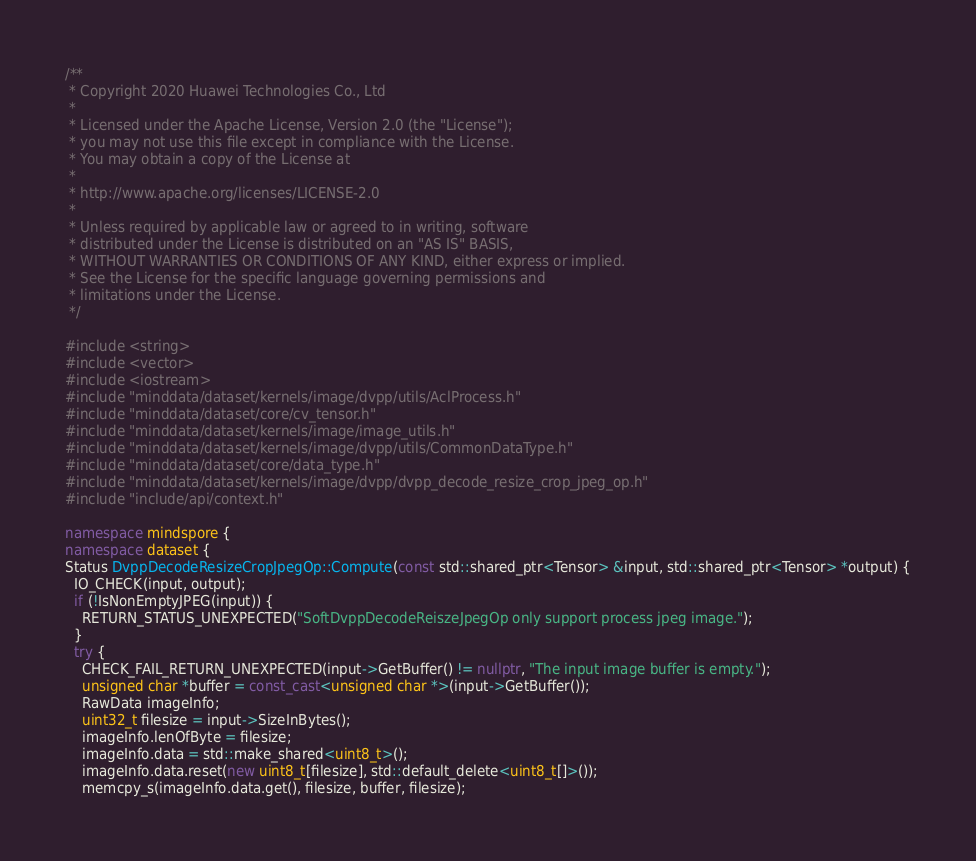<code> <loc_0><loc_0><loc_500><loc_500><_C++_>/**
 * Copyright 2020 Huawei Technologies Co., Ltd
 *
 * Licensed under the Apache License, Version 2.0 (the "License");
 * you may not use this file except in compliance with the License.
 * You may obtain a copy of the License at
 *
 * http://www.apache.org/licenses/LICENSE-2.0
 *
 * Unless required by applicable law or agreed to in writing, software
 * distributed under the License is distributed on an "AS IS" BASIS,
 * WITHOUT WARRANTIES OR CONDITIONS OF ANY KIND, either express or implied.
 * See the License for the specific language governing permissions and
 * limitations under the License.
 */

#include <string>
#include <vector>
#include <iostream>
#include "minddata/dataset/kernels/image/dvpp/utils/AclProcess.h"
#include "minddata/dataset/core/cv_tensor.h"
#include "minddata/dataset/kernels/image/image_utils.h"
#include "minddata/dataset/kernels/image/dvpp/utils/CommonDataType.h"
#include "minddata/dataset/core/data_type.h"
#include "minddata/dataset/kernels/image/dvpp/dvpp_decode_resize_crop_jpeg_op.h"
#include "include/api/context.h"

namespace mindspore {
namespace dataset {
Status DvppDecodeResizeCropJpegOp::Compute(const std::shared_ptr<Tensor> &input, std::shared_ptr<Tensor> *output) {
  IO_CHECK(input, output);
  if (!IsNonEmptyJPEG(input)) {
    RETURN_STATUS_UNEXPECTED("SoftDvppDecodeReiszeJpegOp only support process jpeg image.");
  }
  try {
    CHECK_FAIL_RETURN_UNEXPECTED(input->GetBuffer() != nullptr, "The input image buffer is empty.");
    unsigned char *buffer = const_cast<unsigned char *>(input->GetBuffer());
    RawData imageInfo;
    uint32_t filesize = input->SizeInBytes();
    imageInfo.lenOfByte = filesize;
    imageInfo.data = std::make_shared<uint8_t>();
    imageInfo.data.reset(new uint8_t[filesize], std::default_delete<uint8_t[]>());
    memcpy_s(imageInfo.data.get(), filesize, buffer, filesize);</code> 